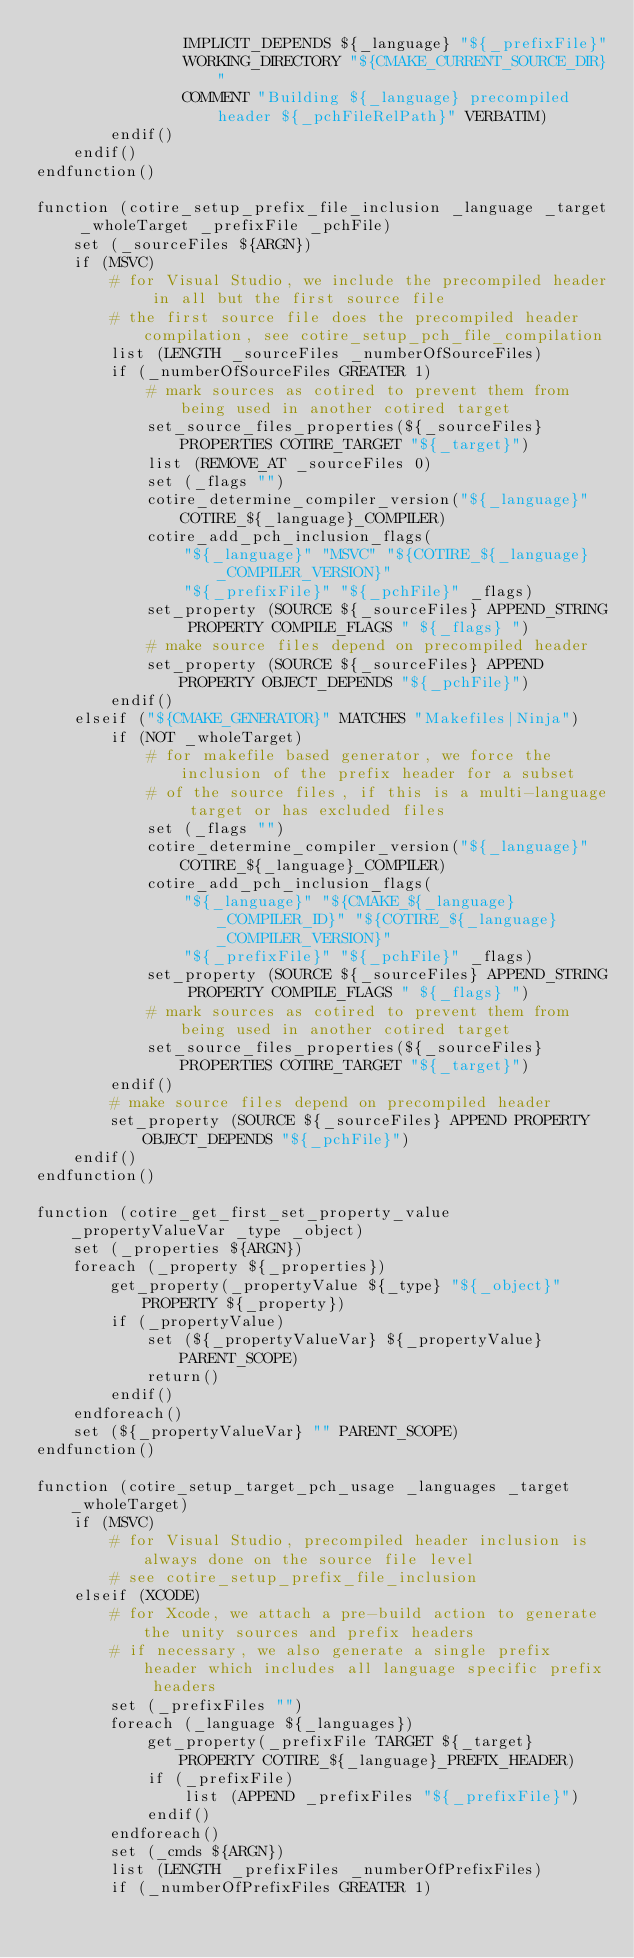Convert code to text. <code><loc_0><loc_0><loc_500><loc_500><_CMake_>				IMPLICIT_DEPENDS ${_language} "${_prefixFile}"
				WORKING_DIRECTORY "${CMAKE_CURRENT_SOURCE_DIR}"
				COMMENT "Building ${_language} precompiled header ${_pchFileRelPath}" VERBATIM)
		endif()
	endif()
endfunction()

function (cotire_setup_prefix_file_inclusion _language _target _wholeTarget _prefixFile _pchFile)
	set (_sourceFiles ${ARGN})
	if (MSVC)
		# for Visual Studio, we include the precompiled header in all but the first source file
		# the first source file does the precompiled header compilation, see cotire_setup_pch_file_compilation
		list (LENGTH _sourceFiles _numberOfSourceFiles)
		if (_numberOfSourceFiles GREATER 1)
			# mark sources as cotired to prevent them from being used in another cotired target
			set_source_files_properties(${_sourceFiles} PROPERTIES COTIRE_TARGET "${_target}")
			list (REMOVE_AT _sourceFiles 0)
			set (_flags "")
			cotire_determine_compiler_version("${_language}" COTIRE_${_language}_COMPILER)
			cotire_add_pch_inclusion_flags(
				"${_language}" "MSVC" "${COTIRE_${_language}_COMPILER_VERSION}"
				"${_prefixFile}" "${_pchFile}" _flags)
			set_property (SOURCE ${_sourceFiles} APPEND_STRING PROPERTY COMPILE_FLAGS " ${_flags} ")
			# make source files depend on precompiled header
			set_property (SOURCE ${_sourceFiles} APPEND PROPERTY OBJECT_DEPENDS "${_pchFile}")
		endif()
	elseif ("${CMAKE_GENERATOR}" MATCHES "Makefiles|Ninja")
		if (NOT _wholeTarget)
			# for makefile based generator, we force the inclusion of the prefix header for a subset
			# of the source files, if this is a multi-language target or has excluded files
			set (_flags "")
			cotire_determine_compiler_version("${_language}" COTIRE_${_language}_COMPILER)
			cotire_add_pch_inclusion_flags(
				"${_language}" "${CMAKE_${_language}_COMPILER_ID}" "${COTIRE_${_language}_COMPILER_VERSION}"
				"${_prefixFile}" "${_pchFile}" _flags)
			set_property (SOURCE ${_sourceFiles} APPEND_STRING PROPERTY COMPILE_FLAGS " ${_flags} ")
			# mark sources as cotired to prevent them from being used in another cotired target
			set_source_files_properties(${_sourceFiles} PROPERTIES COTIRE_TARGET "${_target}")
		endif()
		# make source files depend on precompiled header
		set_property (SOURCE ${_sourceFiles} APPEND PROPERTY OBJECT_DEPENDS "${_pchFile}")
	endif()
endfunction()

function (cotire_get_first_set_property_value _propertyValueVar _type _object)
	set (_properties ${ARGN})
	foreach (_property ${_properties})
		get_property(_propertyValue ${_type} "${_object}" PROPERTY ${_property})
		if (_propertyValue)
			set (${_propertyValueVar} ${_propertyValue} PARENT_SCOPE)
			return()
		endif()
	endforeach()
	set (${_propertyValueVar} "" PARENT_SCOPE)
endfunction()

function (cotire_setup_target_pch_usage _languages _target _wholeTarget)
	if (MSVC)
		# for Visual Studio, precompiled header inclusion is always done on the source file level
		# see cotire_setup_prefix_file_inclusion
	elseif (XCODE)
		# for Xcode, we attach a pre-build action to generate the unity sources and prefix headers
		# if necessary, we also generate a single prefix header which includes all language specific prefix headers
		set (_prefixFiles "")
		foreach (_language ${_languages})
			get_property(_prefixFile TARGET ${_target} PROPERTY COTIRE_${_language}_PREFIX_HEADER)
			if (_prefixFile)
				list (APPEND _prefixFiles "${_prefixFile}")
			endif()
		endforeach()
		set (_cmds ${ARGN})
		list (LENGTH _prefixFiles _numberOfPrefixFiles)
		if (_numberOfPrefixFiles GREATER 1)</code> 